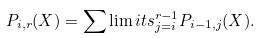Convert formula to latex. <formula><loc_0><loc_0><loc_500><loc_500>P _ { i , r } ( X ) = \sum \lim i t s _ { j = i } ^ { r - 1 } P _ { i - 1 , j } ( X ) .</formula> 